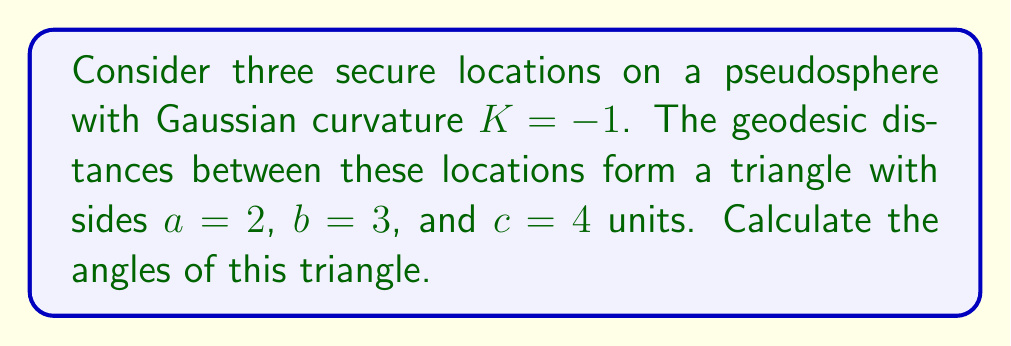Provide a solution to this math problem. To solve this problem, we'll use the hyperbolic law of cosines for a pseudosphere:

$$\cosh c = \cosh a \cosh b - \sinh a \sinh b \cos C$$

Where $C$ is the angle opposite side $c$, and similar equations hold for angles $A$ and $B$.

Step 1: Calculate angle $C$
$$\cosh 4 = \cosh 2 \cosh 3 - \sinh 2 \sinh 3 \cos C$$
$$27.3082 = (3.7622)(10.0677) - (3.6269)(10.0179)\cos C$$
$$27.3082 = 37.8770 - 36.3289\cos C$$
$$\cos C = \frac{37.8770 - 27.3082}{36.3289} = 0.2908$$
$$C = \arccos(0.2908) = 1.2757 \text{ radians}$$

Step 2: Calculate angle $B$
$$\cosh 3 = \cosh 2 \cosh 4 - \sinh 2 \sinh 4 \cos B$$
$$10.0677 = (3.7622)(27.3082) - (3.6269)(27.2899)\cos B$$
$$10.0677 = 102.7594 - 98.9594\cos B$$
$$\cos B = \frac{102.7594 - 10.0677}{98.9594} = 0.9367$$
$$B = \arccos(0.9367) = 0.3581 \text{ radians}$$

Step 3: Calculate angle $A$
Since the sum of angles in a hyperbolic triangle is less than $\pi$, we can find $A$ by subtraction:
$$A = \pi - (B + C) = \pi - (0.3581 + 1.2757) = 1.5078 \text{ radians}$$

Step 4: Convert to degrees
$A = 86.4°$
$B = 20.5°$
$C = 73.1°$

[asy]
import geometry;

size(200);
pair A = (0,0), B = (4,0), C = (1,3);
draw(A--B--C--cycle);
label("A", A, SW);
label("B", B, SE);
label("C", C, N);
label("86.4°", A, NE);
label("20.5°", B, NW);
label("73.1°", C, S);
label("4", (A+B)/2, S);
label("3", (B+C)/2, NE);
label("2", (C+A)/2, NW);
</asy>
Answer: $A = 86.4°$, $B = 20.5°$, $C = 73.1°$ 